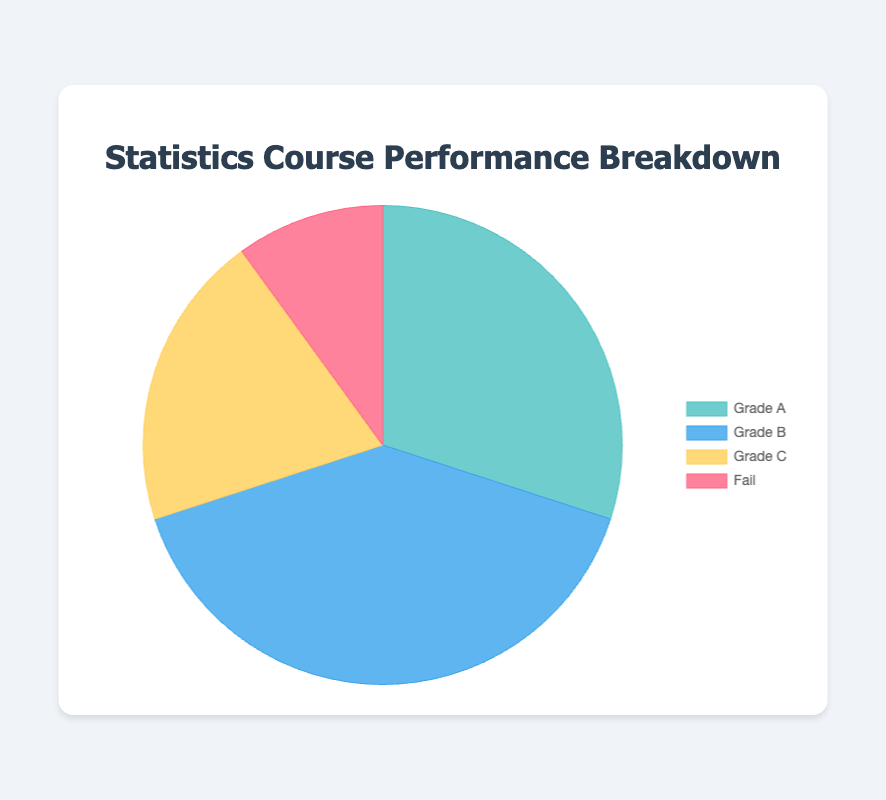What percentage of students achieved Grade A? To find the percentage of students who achieved Grade A, divide the number of students with Grade A by the total number of students, then multiply by 100. So, (150 / 500) * 100 = 30%
Answer: 30% How many more students got Grade B compared to those who failed? Subtract the number of students who failed from those who got Grade B. So, 200 - 50 = 150
Answer: 150 Which grade category has the least number of students? From the data, the category with the least number of students is the Fail category with 50 students.
Answer: Fail What is the combined percentage of students who received either Grade A or Grade C? Add the number of students who got Grade A and Grade C, and then divide by the total number of students, multiply by 100. So, (150 + 100) / 500 * 100 = 50%
Answer: 50% Compare the number of students who received Grade A to the number who received Grade C. Which group is larger and by how much? Subtract the number of students who received Grade C from the number who received Grade A. 150 - 100 = 50. The Grade A group is larger by 50 students.
Answer: Grade A, by 50 students What fraction of students failed the course? Divide the number of failing students by the total number of students. So, 50 / 500 = 1/10
Answer: 1/10 If we were to combine the students who received Grades B and C, what percentage of the total student population would this group represent? Add the number of students who got Grades B and C, and then divide by the total number of students, multiply by 100. So, (200 + 100) / 500 * 100 = 60%
Answer: 60% Which section of the pie chart is represented by the blue color? According to the visual attributes and the legend in the pie chart, the blue color represents the Grade B category.
Answer: Grade B Arrange the grades in descending order based on the number of students who achieved them. From largest to smallest: Grade B (200 students), Grade A (150 students), Grade C (100 students), Fail (50 students)
Answer: Grade B, Grade A, Grade C, Fail 